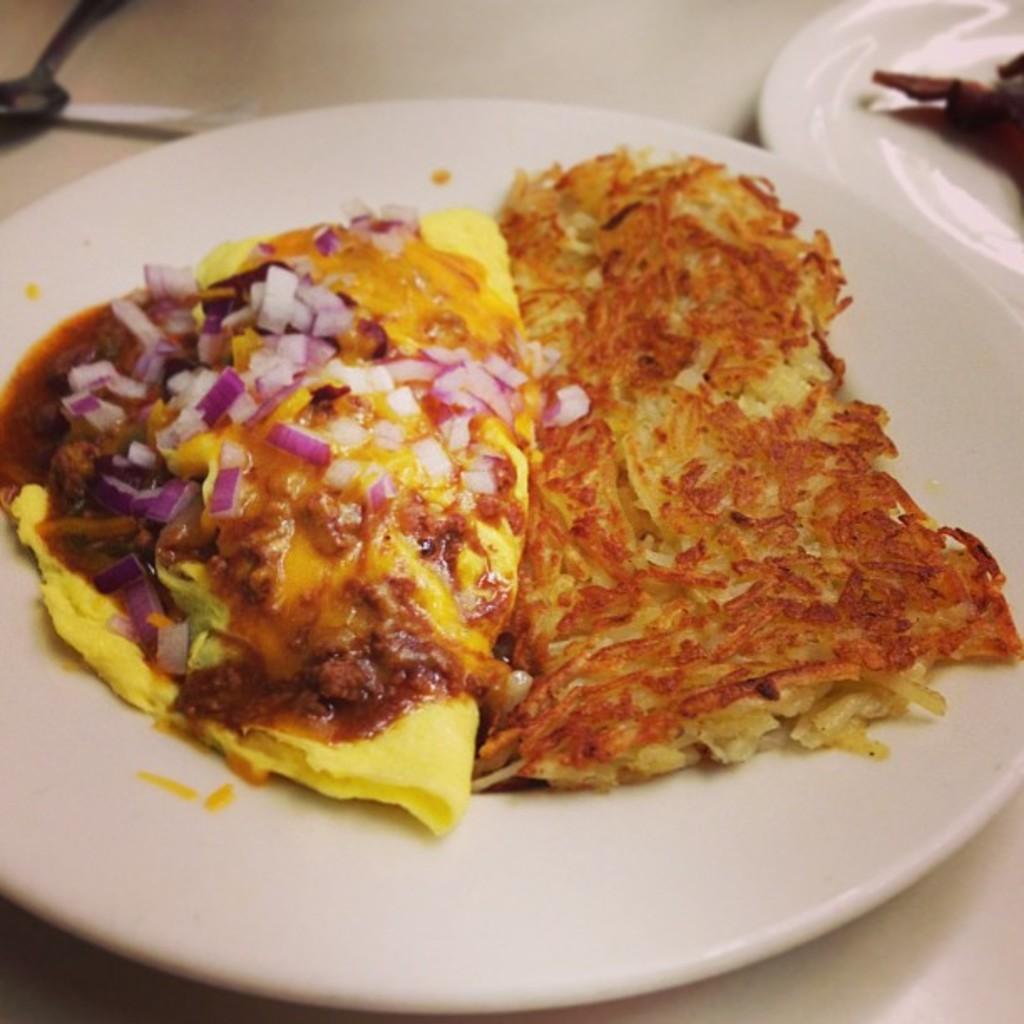Describe this image in one or two sentences. In this image there are some food items arranged on two plates, which is on the table, in front of the plate there is a spoon. 